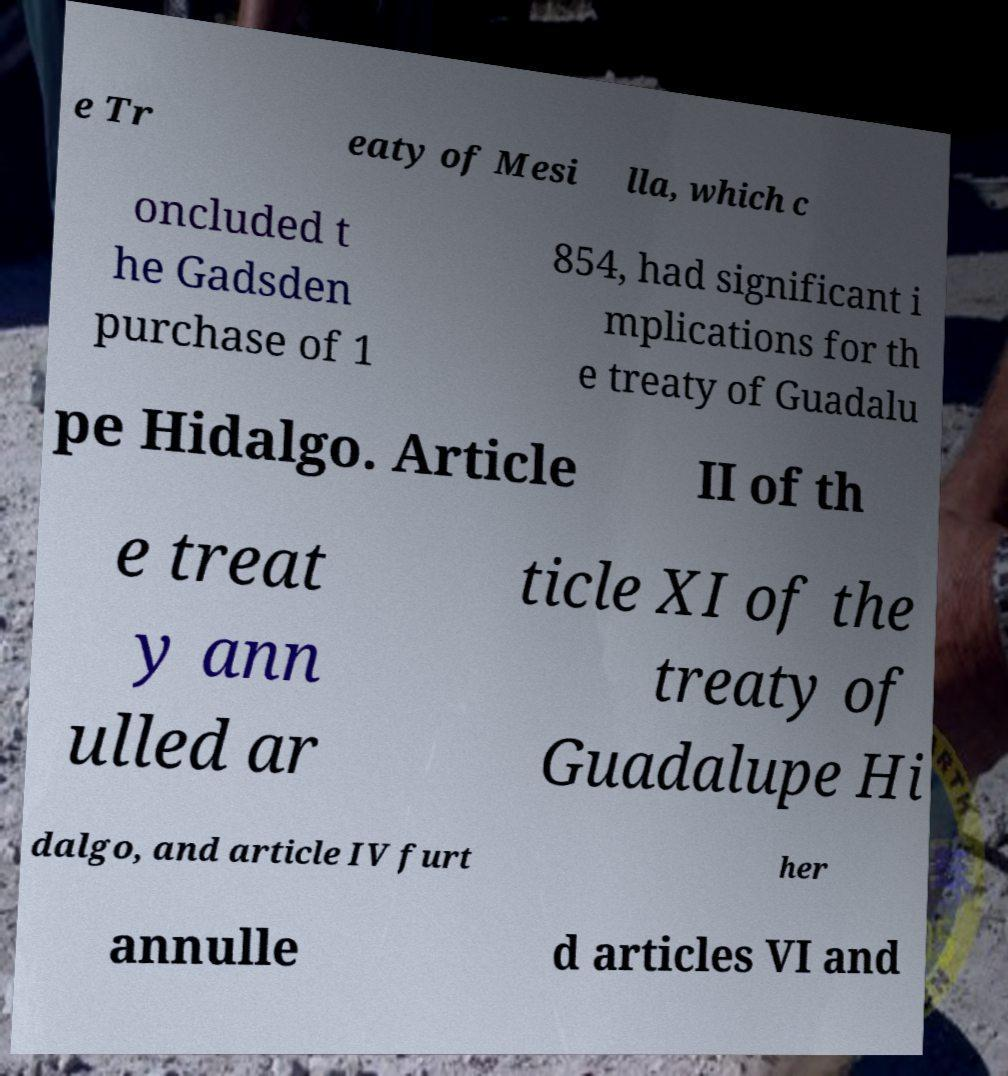What messages or text are displayed in this image? I need them in a readable, typed format. e Tr eaty of Mesi lla, which c oncluded t he Gadsden purchase of 1 854, had significant i mplications for th e treaty of Guadalu pe Hidalgo. Article II of th e treat y ann ulled ar ticle XI of the treaty of Guadalupe Hi dalgo, and article IV furt her annulle d articles VI and 